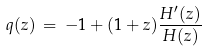<formula> <loc_0><loc_0><loc_500><loc_500>q ( z ) \, = \, - 1 + ( 1 + z ) \frac { H ^ { \prime } ( z ) } { H ( z ) }</formula> 